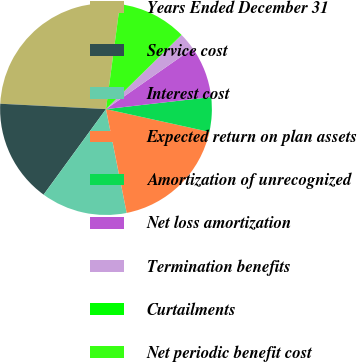Convert chart to OTSL. <chart><loc_0><loc_0><loc_500><loc_500><pie_chart><fcel>Years Ended December 31<fcel>Service cost<fcel>Interest cost<fcel>Expected return on plan assets<fcel>Amortization of unrecognized<fcel>Net loss amortization<fcel>Termination benefits<fcel>Curtailments<fcel>Net periodic benefit cost<nl><fcel>26.3%<fcel>15.78%<fcel>13.16%<fcel>18.41%<fcel>5.27%<fcel>7.9%<fcel>2.64%<fcel>0.01%<fcel>10.53%<nl></chart> 